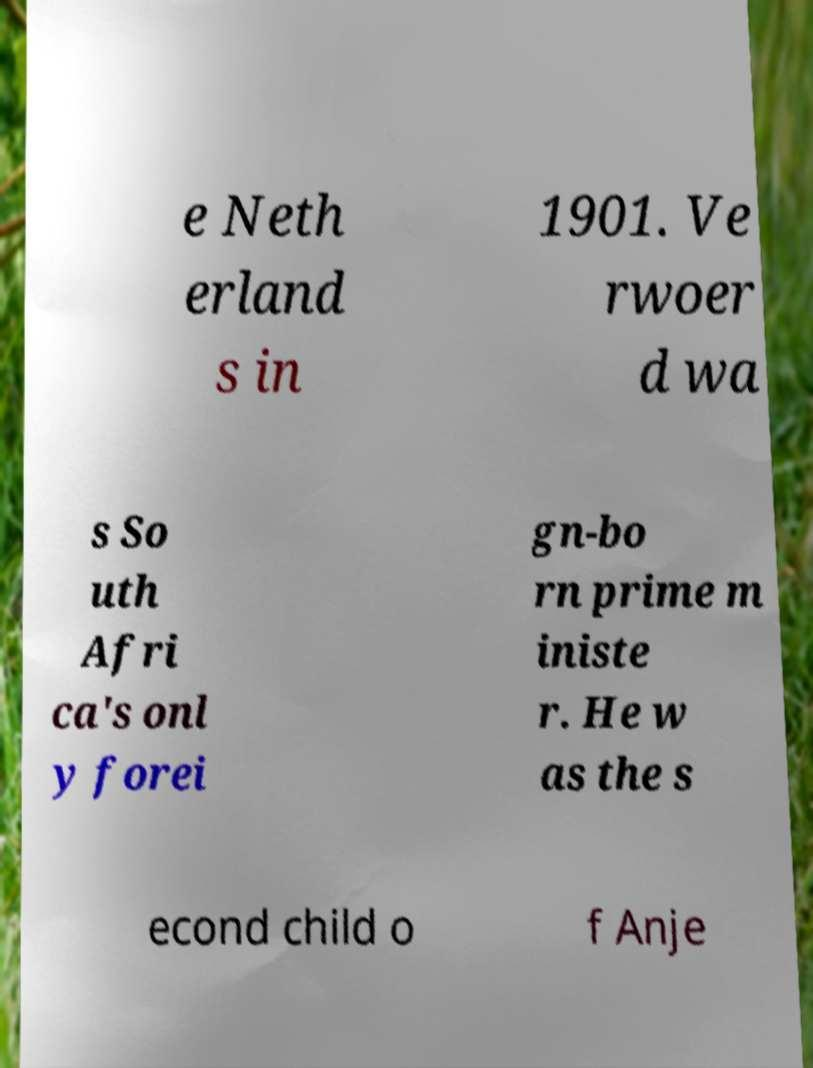I need the written content from this picture converted into text. Can you do that? e Neth erland s in 1901. Ve rwoer d wa s So uth Afri ca's onl y forei gn-bo rn prime m iniste r. He w as the s econd child o f Anje 